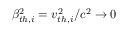Convert formula to latex. <formula><loc_0><loc_0><loc_500><loc_500>\beta _ { t h , i } ^ { 2 } = v _ { t h , i } ^ { 2 } / c ^ { 2 } \rightarrow 0</formula> 